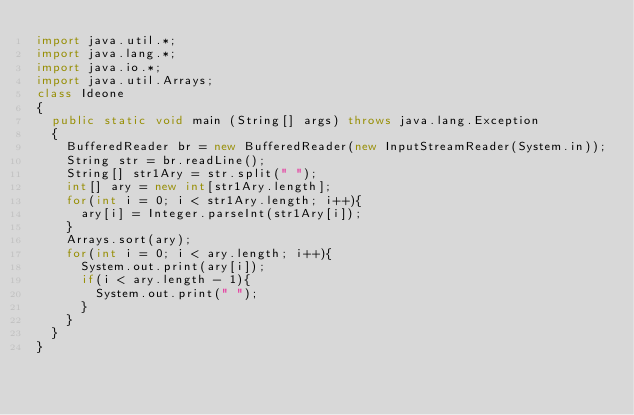<code> <loc_0><loc_0><loc_500><loc_500><_Java_>import java.util.*;
import java.lang.*;
import java.io.*;
import java.util.Arrays;
class Ideone
{
	public static void main (String[] args) throws java.lang.Exception
	{
		BufferedReader br = new BufferedReader(new InputStreamReader(System.in));
		String str = br.readLine();
		String[] str1Ary = str.split(" ");
		int[] ary = new int[str1Ary.length];
		for(int i = 0; i < str1Ary.length; i++){
			ary[i] = Integer.parseInt(str1Ary[i]);
		}
		Arrays.sort(ary);
		for(int i = 0; i < ary.length; i++){
			System.out.print(ary[i]);
			if(i < ary.length - 1){
				System.out.print(" ");
			}
		}
	}
}</code> 